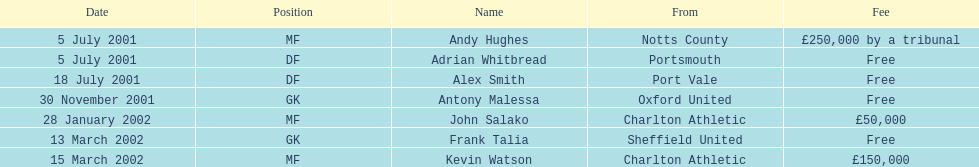When was the transfer date for both andy hughes and adrian whitbread? 5 July 2001. 